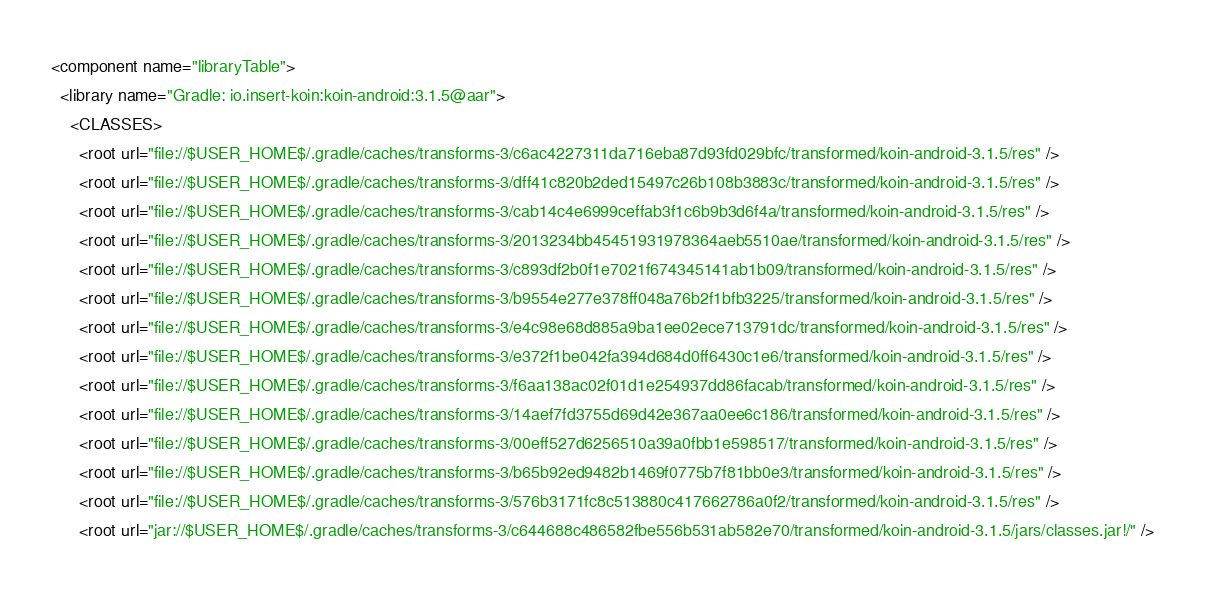<code> <loc_0><loc_0><loc_500><loc_500><_XML_><component name="libraryTable">
  <library name="Gradle: io.insert-koin:koin-android:3.1.5@aar">
    <CLASSES>
      <root url="file://$USER_HOME$/.gradle/caches/transforms-3/c6ac4227311da716eba87d93fd029bfc/transformed/koin-android-3.1.5/res" />
      <root url="file://$USER_HOME$/.gradle/caches/transforms-3/dff41c820b2ded15497c26b108b3883c/transformed/koin-android-3.1.5/res" />
      <root url="file://$USER_HOME$/.gradle/caches/transforms-3/cab14c4e6999ceffab3f1c6b9b3d6f4a/transformed/koin-android-3.1.5/res" />
      <root url="file://$USER_HOME$/.gradle/caches/transforms-3/2013234bb45451931978364aeb5510ae/transformed/koin-android-3.1.5/res" />
      <root url="file://$USER_HOME$/.gradle/caches/transforms-3/c893df2b0f1e7021f674345141ab1b09/transformed/koin-android-3.1.5/res" />
      <root url="file://$USER_HOME$/.gradle/caches/transforms-3/b9554e277e378ff048a76b2f1bfb3225/transformed/koin-android-3.1.5/res" />
      <root url="file://$USER_HOME$/.gradle/caches/transforms-3/e4c98e68d885a9ba1ee02ece713791dc/transformed/koin-android-3.1.5/res" />
      <root url="file://$USER_HOME$/.gradle/caches/transforms-3/e372f1be042fa394d684d0ff6430c1e6/transformed/koin-android-3.1.5/res" />
      <root url="file://$USER_HOME$/.gradle/caches/transforms-3/f6aa138ac02f01d1e254937dd86facab/transformed/koin-android-3.1.5/res" />
      <root url="file://$USER_HOME$/.gradle/caches/transforms-3/14aef7fd3755d69d42e367aa0ee6c186/transformed/koin-android-3.1.5/res" />
      <root url="file://$USER_HOME$/.gradle/caches/transforms-3/00eff527d6256510a39a0fbb1e598517/transformed/koin-android-3.1.5/res" />
      <root url="file://$USER_HOME$/.gradle/caches/transforms-3/b65b92ed9482b1469f0775b7f81bb0e3/transformed/koin-android-3.1.5/res" />
      <root url="file://$USER_HOME$/.gradle/caches/transforms-3/576b3171fc8c513880c417662786a0f2/transformed/koin-android-3.1.5/res" />
      <root url="jar://$USER_HOME$/.gradle/caches/transforms-3/c644688c486582fbe556b531ab582e70/transformed/koin-android-3.1.5/jars/classes.jar!/" /></code> 